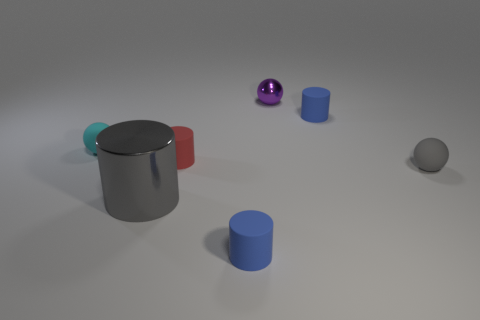What is the material of the sphere that is the same color as the big metallic thing?
Your answer should be very brief. Rubber. What number of other objects are the same color as the metallic cylinder?
Your response must be concise. 1. Do the shiny ball and the matte cylinder that is behind the cyan rubber thing have the same color?
Your answer should be compact. No. What color is the other rubber object that is the same shape as the tiny gray thing?
Provide a succinct answer. Cyan. Do the purple ball and the tiny blue thing behind the cyan rubber thing have the same material?
Make the answer very short. No. What is the color of the big metal cylinder?
Your answer should be compact. Gray. There is a tiny object that is behind the blue rubber object behind the rubber cylinder that is in front of the big object; what color is it?
Your answer should be compact. Purple. There is a tiny cyan matte object; does it have the same shape as the blue thing that is behind the shiny cylinder?
Your response must be concise. No. There is a rubber cylinder that is in front of the tiny cyan thing and behind the gray metallic object; what is its color?
Offer a very short reply. Red. Are there any other large objects that have the same shape as the gray rubber thing?
Provide a short and direct response. No. 